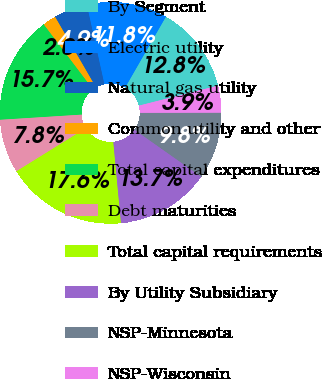<chart> <loc_0><loc_0><loc_500><loc_500><pie_chart><fcel>By Segment<fcel>Electric utility<fcel>Natural gas utility<fcel>Common utility and other<fcel>Total capital expenditures<fcel>Debt maturities<fcel>Total capital requirements<fcel>By Utility Subsidiary<fcel>NSP-Minnesota<fcel>NSP-Wisconsin<nl><fcel>12.75%<fcel>11.76%<fcel>4.9%<fcel>1.96%<fcel>15.69%<fcel>7.84%<fcel>17.65%<fcel>13.73%<fcel>9.8%<fcel>3.92%<nl></chart> 